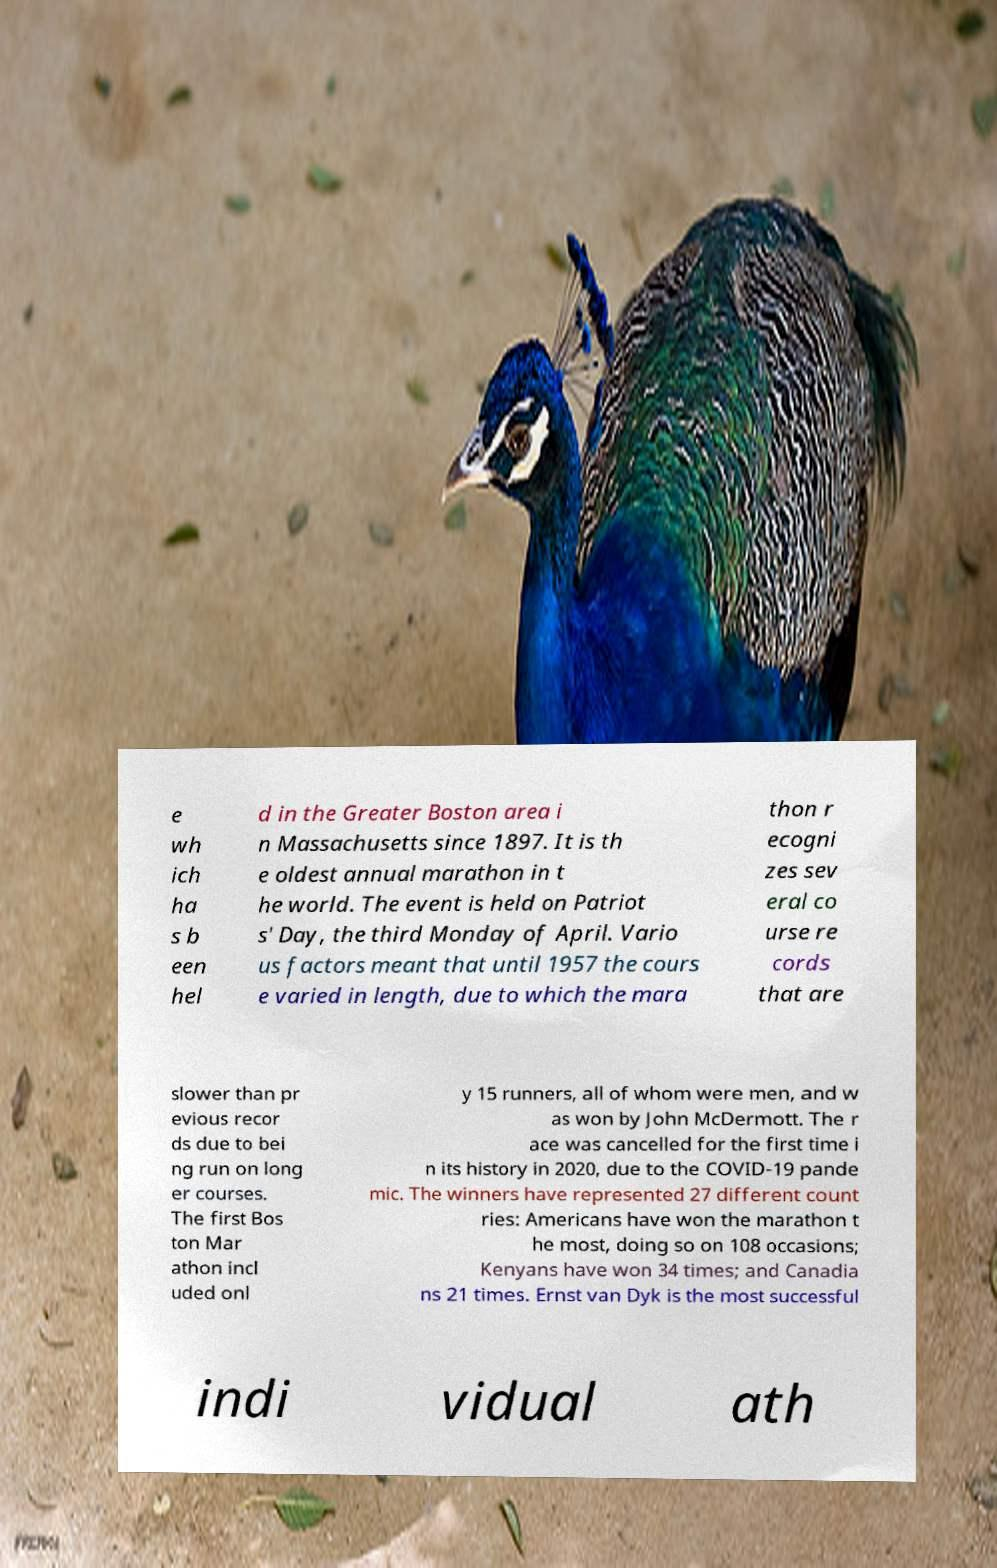For documentation purposes, I need the text within this image transcribed. Could you provide that? e wh ich ha s b een hel d in the Greater Boston area i n Massachusetts since 1897. It is th e oldest annual marathon in t he world. The event is held on Patriot s' Day, the third Monday of April. Vario us factors meant that until 1957 the cours e varied in length, due to which the mara thon r ecogni zes sev eral co urse re cords that are slower than pr evious recor ds due to bei ng run on long er courses. The first Bos ton Mar athon incl uded onl y 15 runners, all of whom were men, and w as won by John McDermott. The r ace was cancelled for the first time i n its history in 2020, due to the COVID-19 pande mic. The winners have represented 27 different count ries: Americans have won the marathon t he most, doing so on 108 occasions; Kenyans have won 34 times; and Canadia ns 21 times. Ernst van Dyk is the most successful indi vidual ath 